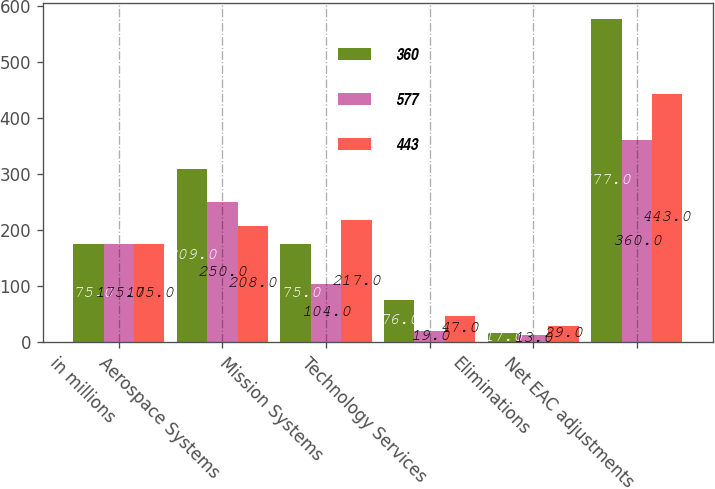Convert chart to OTSL. <chart><loc_0><loc_0><loc_500><loc_500><stacked_bar_chart><ecel><fcel>in millions<fcel>Aerospace Systems<fcel>Mission Systems<fcel>Technology Services<fcel>Eliminations<fcel>Net EAC adjustments<nl><fcel>360<fcel>175<fcel>309<fcel>175<fcel>76<fcel>17<fcel>577<nl><fcel>577<fcel>175<fcel>250<fcel>104<fcel>19<fcel>13<fcel>360<nl><fcel>443<fcel>175<fcel>208<fcel>217<fcel>47<fcel>29<fcel>443<nl></chart> 